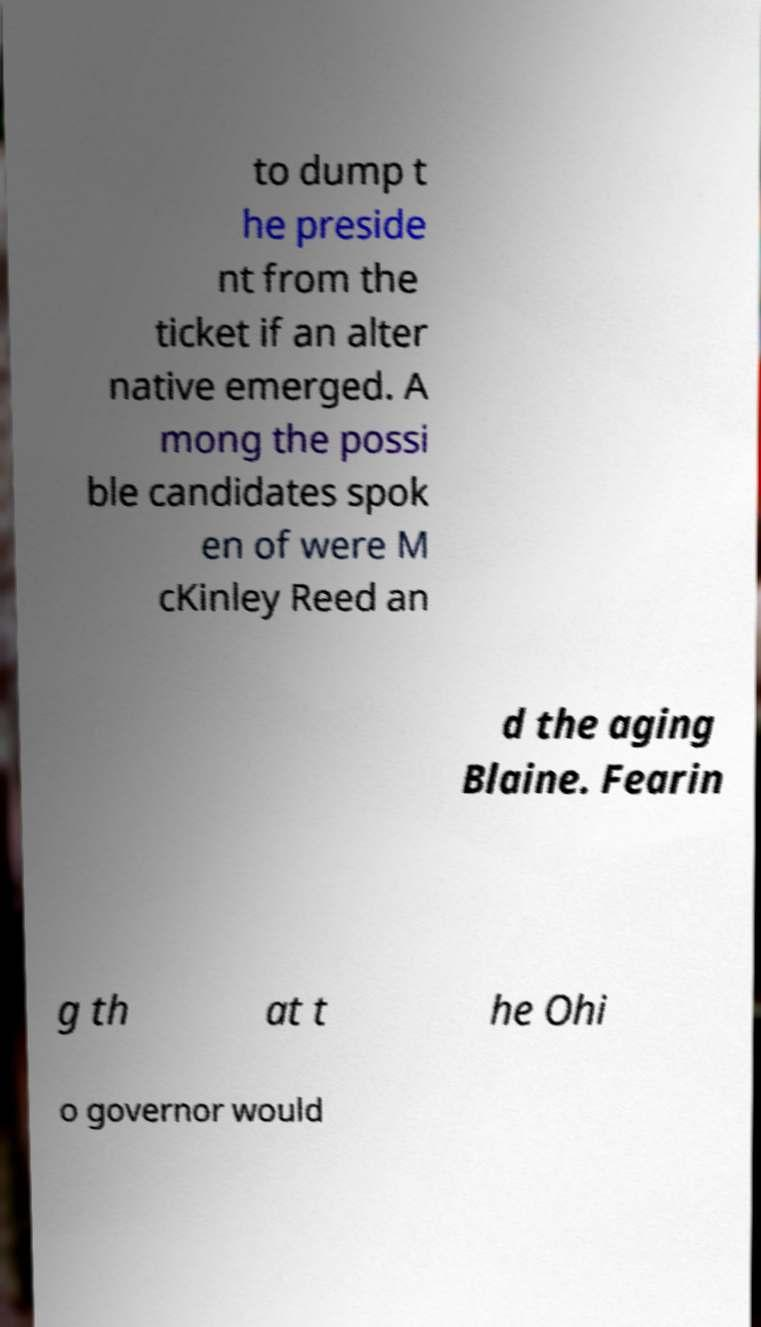For documentation purposes, I need the text within this image transcribed. Could you provide that? to dump t he preside nt from the ticket if an alter native emerged. A mong the possi ble candidates spok en of were M cKinley Reed an d the aging Blaine. Fearin g th at t he Ohi o governor would 